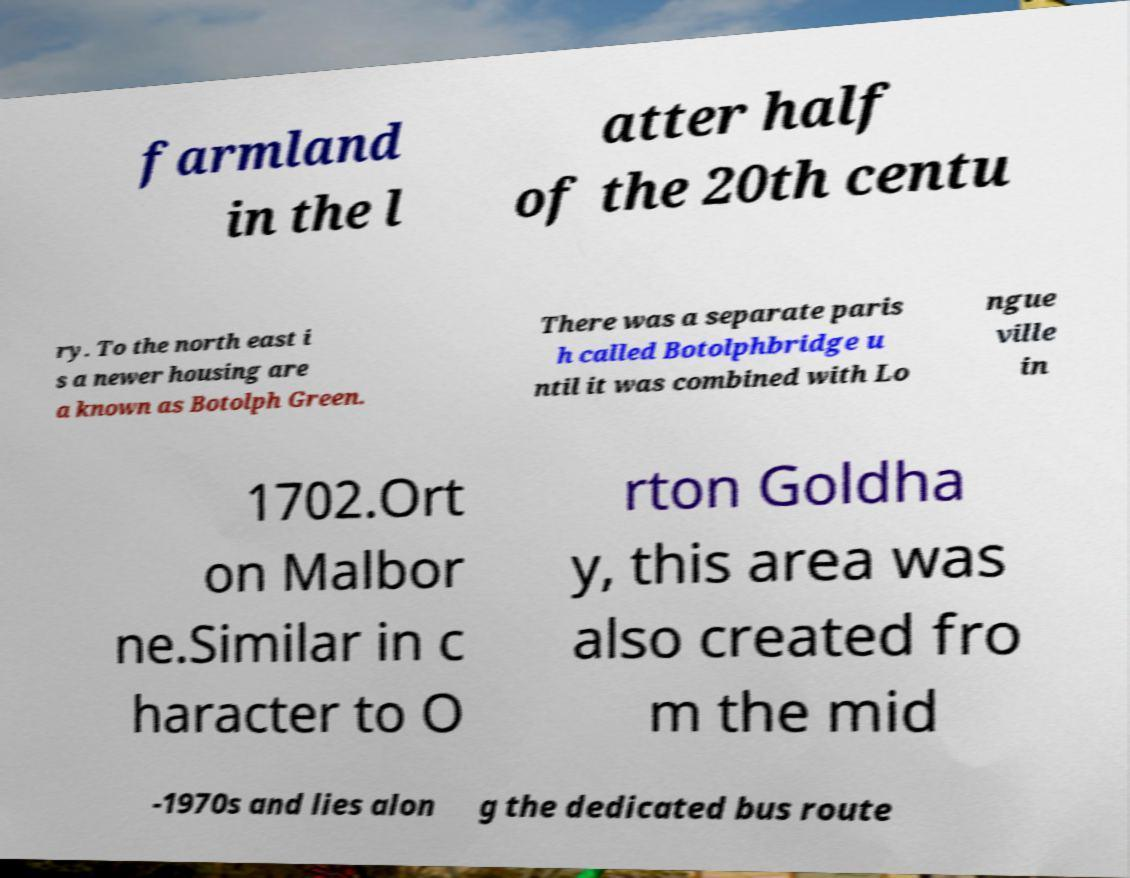Please identify and transcribe the text found in this image. farmland in the l atter half of the 20th centu ry. To the north east i s a newer housing are a known as Botolph Green. There was a separate paris h called Botolphbridge u ntil it was combined with Lo ngue ville in 1702.Ort on Malbor ne.Similar in c haracter to O rton Goldha y, this area was also created fro m the mid -1970s and lies alon g the dedicated bus route 